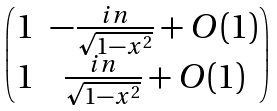Convert formula to latex. <formula><loc_0><loc_0><loc_500><loc_500>\begin{pmatrix} 1 & - \frac { i n } { \sqrt { 1 - x ^ { 2 } } } + O ( 1 ) \\ 1 & \frac { i n } { \sqrt { 1 - x ^ { 2 } } } + O ( 1 ) \end{pmatrix}</formula> 